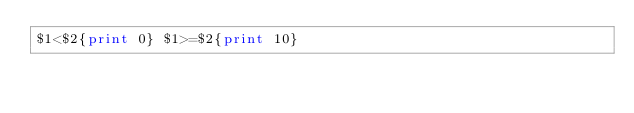<code> <loc_0><loc_0><loc_500><loc_500><_Awk_>$1<$2{print 0} $1>=$2{print 10}</code> 